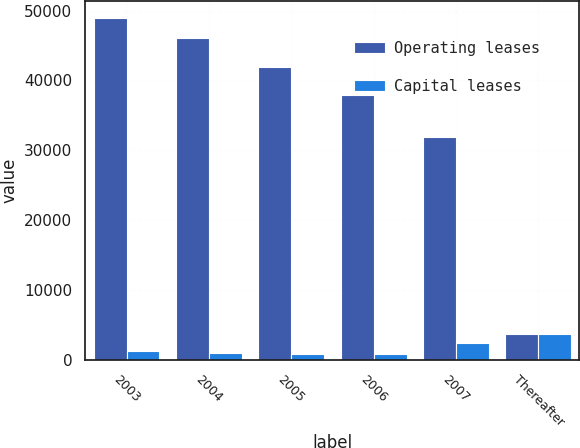Convert chart. <chart><loc_0><loc_0><loc_500><loc_500><stacked_bar_chart><ecel><fcel>2003<fcel>2004<fcel>2005<fcel>2006<fcel>2007<fcel>Thereafter<nl><fcel>Operating leases<fcel>48916<fcel>46067<fcel>41959<fcel>37930<fcel>31902<fcel>3738<nl><fcel>Capital leases<fcel>1289<fcel>924<fcel>811<fcel>810<fcel>2389<fcel>3738<nl></chart> 